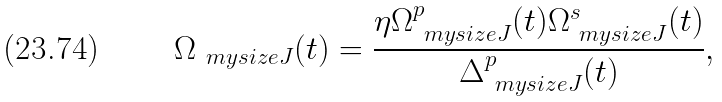<formula> <loc_0><loc_0><loc_500><loc_500>\Omega _ { \ m y s i z e J } ( t ) = \frac { \eta \Omega ^ { p } _ { \ m y s i z e J } ( t ) \Omega ^ { s } _ { \ m y s i z e J } ( t ) } { \Delta ^ { p } _ { \ m y s i z e J } ( t ) } ,</formula> 